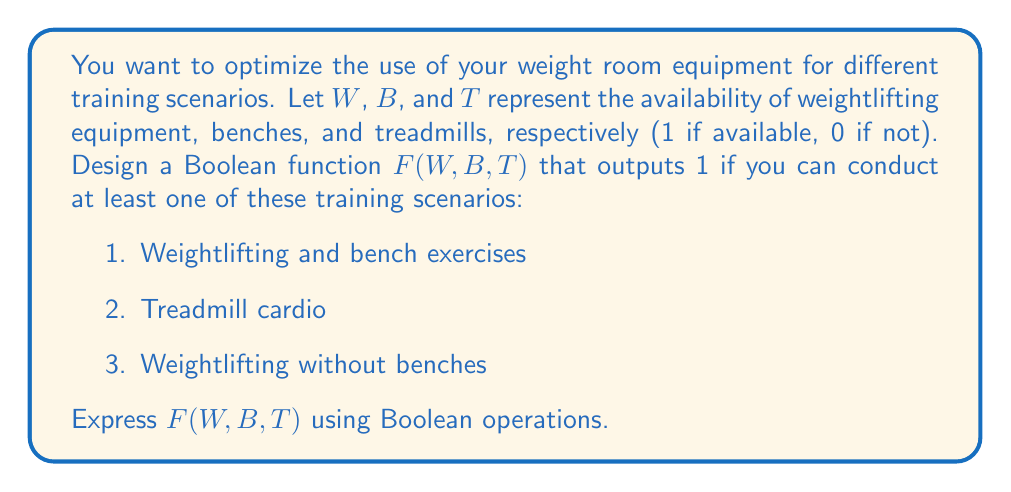Could you help me with this problem? Let's approach this step-by-step:

1) First, let's define Boolean expressions for each training scenario:
   - Weightlifting and bench exercises: $W \cdot B$
   - Treadmill cardio: $T$
   - Weightlifting without benches: $W \cdot \overline{B}$

2) We want the function to output 1 if at least one of these scenarios is possible. In Boolean algebra, this is represented by the OR operation.

3) Therefore, our function $F(W,B,T)$ should be:

   $F(W,B,T) = (W \cdot B) + T + (W \cdot \overline{B})$

4) We can simplify this expression:
   
   $F(W,B,T) = (W \cdot B) + T + (W \cdot \overline{B})$
              $= W \cdot (B + \overline{B}) + T$
              $= W \cdot 1 + T$
              $= W + T$

5) The final simplified Boolean function is $F(W,B,T) = W + T$

This function will output 1 if either weightlifting equipment (W) or treadmills (T) are available, regardless of the availability of benches (B).
Answer: $F(W,B,T) = W + T$ 